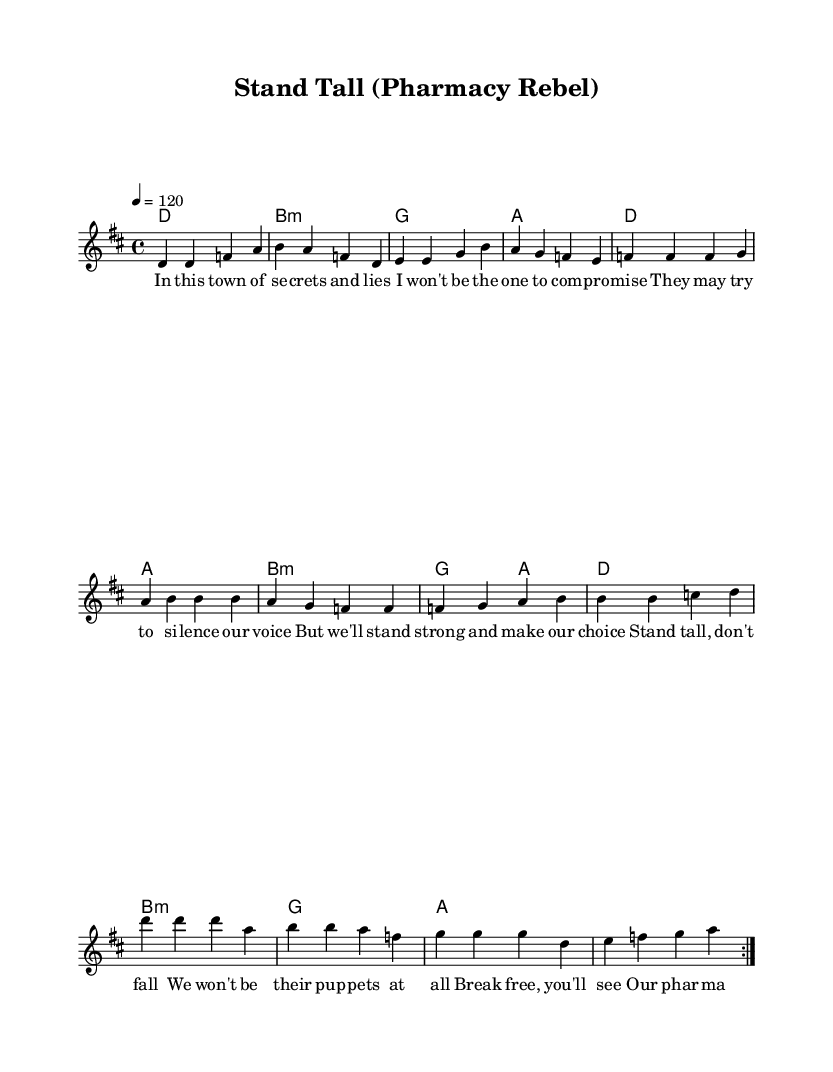what is the key signature of this music? The key signature is D major, which has two sharps (F# and C#). This can be identified in the global section of the code which states "\key d \major".
Answer: D major what is the time signature of this music? The time signature is 4/4, which is indicated in the global section of the code with "\time 4/4". This means there are four beats in each measure and the quarter note gets one beat.
Answer: 4/4 what is the tempo marking of this music? The tempo marking is quarter note equals 120 beats per minute, as indicated by "\tempo 4 = 120" in the global section. This means the piece should be played at a moderately fast pace.
Answer: 120 how many verses are included in the melody? There is one verse included in the melody, as seen in the repeated section marked with "\repeat volta 2" and the presence of verse lyrics.
Answer: One verse what is the main theme of the chorus? The main theme of the chorus is standing up against oppression and celebrating independence, as shown in the lyrics "Stand tall, don't fall / We won't be their puppets at all." This conveys a strong message of resistance and empowerment.
Answer: Independence how many chords are used in the verse section? There are four chords used in the verse section: D major, B minor, G major, and A major. Each chord corresponds to a measure in the harmony section.
Answer: Four chords what type of lyrics does this piece utilize? The lyrics utilize a narrative style that conveys themes of rebellion and empowerment, common in pop anthems focusing on independence. This can be inferred from phrases like "our pharmacy will set us free" in the chorus.
Answer: Narrative style 